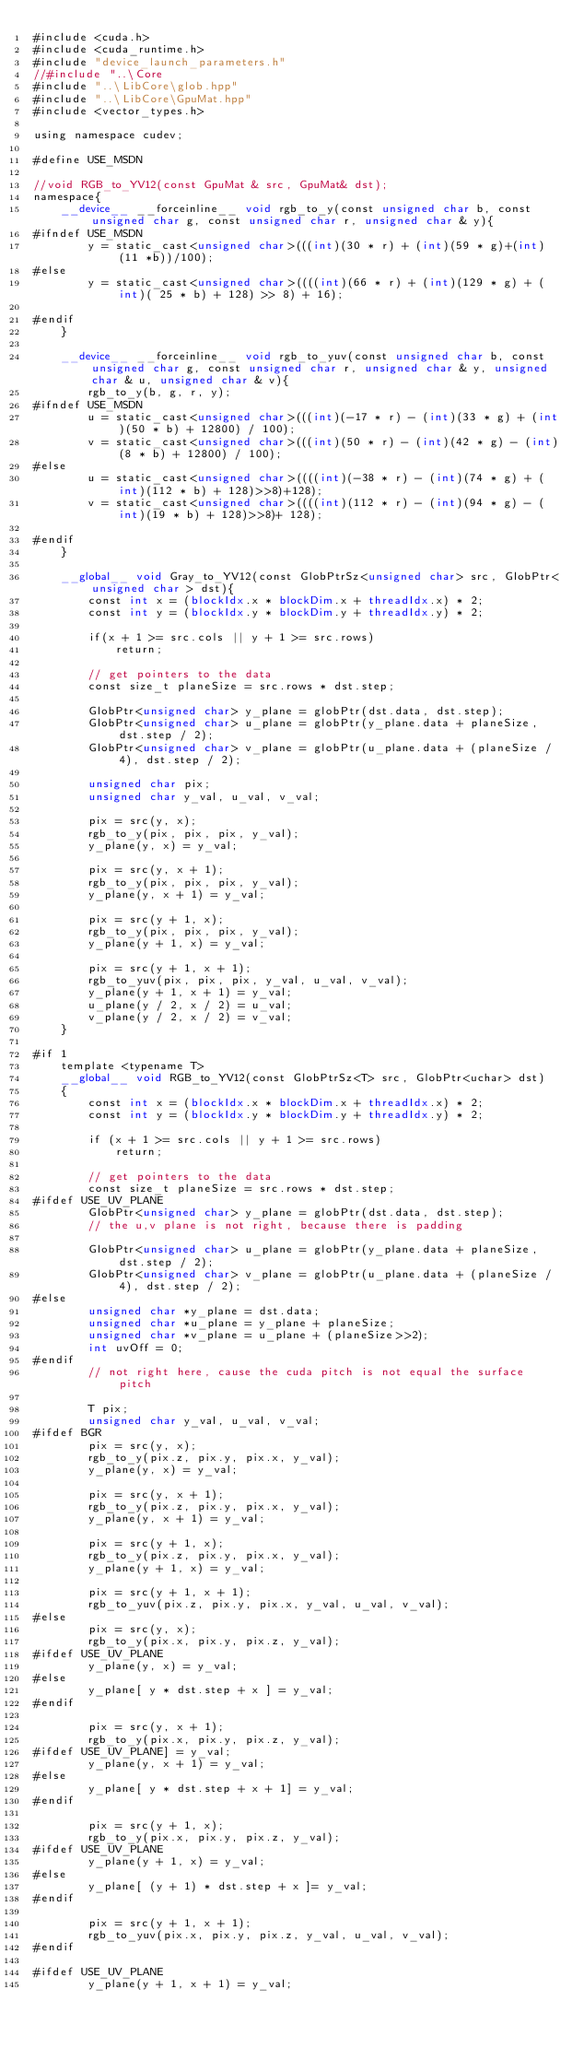Convert code to text. <code><loc_0><loc_0><loc_500><loc_500><_Cuda_>#include <cuda.h>
#include <cuda_runtime.h>
#include "device_launch_parameters.h"
//#include "..\Core
#include "..\LibCore\glob.hpp"
#include "..\LibCore\GpuMat.hpp"
#include <vector_types.h>

using namespace cudev;

#define USE_MSDN

//void RGB_to_YV12(const GpuMat & src, GpuMat& dst);
namespace{
	__device__ __forceinline__ void rgb_to_y(const unsigned char b, const unsigned char g, const unsigned char r, unsigned char & y){
#ifndef USE_MSDN
		y = static_cast<unsigned char>(((int)(30 * r) + (int)(59 * g)+(int)(11 *b))/100);
#else
		y = static_cast<unsigned char>((((int)(66 * r) + (int)(129 * g) + (int)( 25 * b) + 128) >> 8) + 16);

#endif
	}

	__device__ __forceinline__ void rgb_to_yuv(const unsigned char b, const unsigned char g, const unsigned char r, unsigned char & y, unsigned char & u, unsigned char & v){
		rgb_to_y(b, g, r, y);
#ifndef USE_MSDN
		u = static_cast<unsigned char>(((int)(-17 * r) - (int)(33 * g) + (int)(50 * b) + 12800) / 100);
		v = static_cast<unsigned char>(((int)(50 * r) - (int)(42 * g) - (int)(8 * b) + 12800) / 100);
#else
		u = static_cast<unsigned char>((((int)(-38 * r) - (int)(74 * g) + (int)(112 * b) + 128)>>8)+128);
		v = static_cast<unsigned char>((((int)(112 * r) - (int)(94 * g) - (int)(19 * b) + 128)>>8)+ 128);

#endif
	}

	__global__ void Gray_to_YV12(const GlobPtrSz<unsigned char> src, GlobPtr<unsigned char > dst){
		const int x = (blockIdx.x * blockDim.x + threadIdx.x) * 2;
		const int y = (blockIdx.y * blockDim.y + threadIdx.y) * 2;

		if(x + 1 >= src.cols || y + 1 >= src.rows)
			return;

		// get pointers to the data
		const size_t planeSize = src.rows * dst.step;

		GlobPtr<unsigned char> y_plane = globPtr(dst.data, dst.step);
		GlobPtr<unsigned char> u_plane = globPtr(y_plane.data + planeSize, dst.step / 2);
		GlobPtr<unsigned char> v_plane = globPtr(u_plane.data + (planeSize / 4), dst.step / 2);

		unsigned char pix;
		unsigned char y_val, u_val, v_val;

		pix = src(y, x);
        rgb_to_y(pix, pix, pix, y_val);
        y_plane(y, x) = y_val;

        pix = src(y, x + 1);
        rgb_to_y(pix, pix, pix, y_val);
        y_plane(y, x + 1) = y_val;

        pix = src(y + 1, x);
        rgb_to_y(pix, pix, pix, y_val);
        y_plane(y + 1, x) = y_val;

        pix = src(y + 1, x + 1);
        rgb_to_yuv(pix, pix, pix, y_val, u_val, v_val);
        y_plane(y + 1, x + 1) = y_val;
        u_plane(y / 2, x / 2) = u_val;
        v_plane(y / 2, x / 2) = v_val;
	}
	
#if 1	
	template <typename T>
    __global__ void RGB_to_YV12(const GlobPtrSz<T> src, GlobPtr<uchar> dst)
    {
        const int x = (blockIdx.x * blockDim.x + threadIdx.x) * 2;
        const int y = (blockIdx.y * blockDim.y + threadIdx.y) * 2;

        if (x + 1 >= src.cols || y + 1 >= src.rows)
            return;

        // get pointers to the data
        const size_t planeSize = src.rows * dst.step;
#ifdef USE_UV_PLANE
        GlobPtr<unsigned char> y_plane = globPtr(dst.data, dst.step);
		// the u,v plane is not right, because there is padding

        GlobPtr<unsigned char> u_plane = globPtr(y_plane.data + planeSize, dst.step / 2);
        GlobPtr<unsigned char> v_plane = globPtr(u_plane.data + (planeSize / 4), dst.step / 2);
#else
		unsigned char *y_plane = dst.data;
		unsigned char *u_plane = y_plane + planeSize;
		unsigned char *v_plane = u_plane + (planeSize>>2);
		int uvOff = 0;
#endif
		// not right here, cause the cuda pitch is not equal the surface pitch

        T pix;
        unsigned char y_val, u_val, v_val;
#ifdef BGR
        pix = src(y, x);
        rgb_to_y(pix.z, pix.y, pix.x, y_val);
        y_plane(y, x) = y_val;

        pix = src(y, x + 1);
        rgb_to_y(pix.z, pix.y, pix.x, y_val);
        y_plane(y, x + 1) = y_val;

        pix = src(y + 1, x);
        rgb_to_y(pix.z, pix.y, pix.x, y_val);
        y_plane(y + 1, x) = y_val;

        pix = src(y + 1, x + 1);
        rgb_to_yuv(pix.z, pix.y, pix.x, y_val, u_val, v_val);
#else
		pix = src(y, x);
        rgb_to_y(pix.x, pix.y, pix.z, y_val);
#ifdef USE_UV_PLANE
        y_plane(y, x) = y_val;
#else
		y_plane[ y * dst.step + x ] = y_val;
#endif

        pix = src(y, x + 1);
        rgb_to_y(pix.x, pix.y, pix.z, y_val);
#ifdef USE_UV_PLANE] = y_val;
        y_plane(y, x + 1) = y_val;
#else
		y_plane[ y * dst.step + x + 1] = y_val;
#endif

        pix = src(y + 1, x);
        rgb_to_y(pix.x, pix.y, pix.z, y_val);
#ifdef USE_UV_PLANE
        y_plane(y + 1, x) = y_val;
#else
		y_plane[ (y + 1) * dst.step + x ]= y_val;
#endif

        pix = src(y + 1, x + 1);
        rgb_to_yuv(pix.x, pix.y, pix.z, y_val, u_val, v_val);
#endif

#ifdef USE_UV_PLANE
        y_plane(y + 1, x + 1) = y_val;</code> 